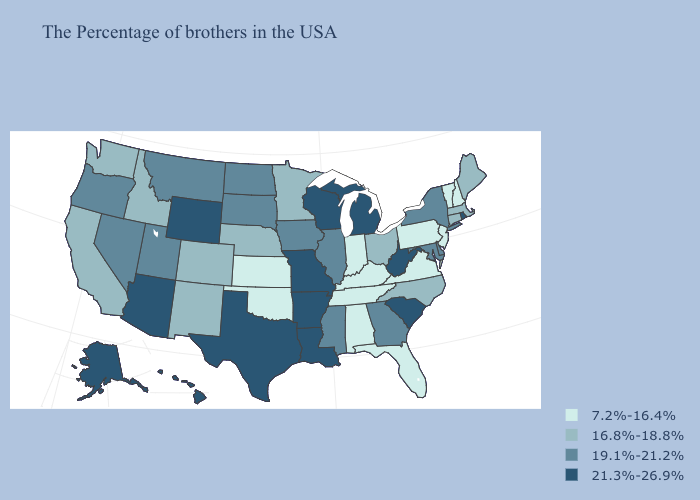Which states have the lowest value in the MidWest?
Keep it brief. Indiana, Kansas. Among the states that border Nevada , which have the highest value?
Write a very short answer. Arizona. Does Maine have the lowest value in the Northeast?
Quick response, please. No. Does Oregon have a higher value than Utah?
Write a very short answer. No. Does Florida have the lowest value in the USA?
Keep it brief. Yes. Does Oklahoma have the lowest value in the USA?
Quick response, please. Yes. Which states have the highest value in the USA?
Concise answer only. Rhode Island, South Carolina, West Virginia, Michigan, Wisconsin, Louisiana, Missouri, Arkansas, Texas, Wyoming, Arizona, Alaska, Hawaii. What is the value of Oklahoma?
Write a very short answer. 7.2%-16.4%. What is the value of Kentucky?
Be succinct. 7.2%-16.4%. Name the states that have a value in the range 16.8%-18.8%?
Write a very short answer. Maine, Massachusetts, Connecticut, North Carolina, Ohio, Minnesota, Nebraska, Colorado, New Mexico, Idaho, California, Washington. Which states hav the highest value in the South?
Short answer required. South Carolina, West Virginia, Louisiana, Arkansas, Texas. Among the states that border New Hampshire , does Maine have the lowest value?
Concise answer only. No. Name the states that have a value in the range 21.3%-26.9%?
Write a very short answer. Rhode Island, South Carolina, West Virginia, Michigan, Wisconsin, Louisiana, Missouri, Arkansas, Texas, Wyoming, Arizona, Alaska, Hawaii. Name the states that have a value in the range 21.3%-26.9%?
Answer briefly. Rhode Island, South Carolina, West Virginia, Michigan, Wisconsin, Louisiana, Missouri, Arkansas, Texas, Wyoming, Arizona, Alaska, Hawaii. Which states hav the highest value in the MidWest?
Keep it brief. Michigan, Wisconsin, Missouri. 